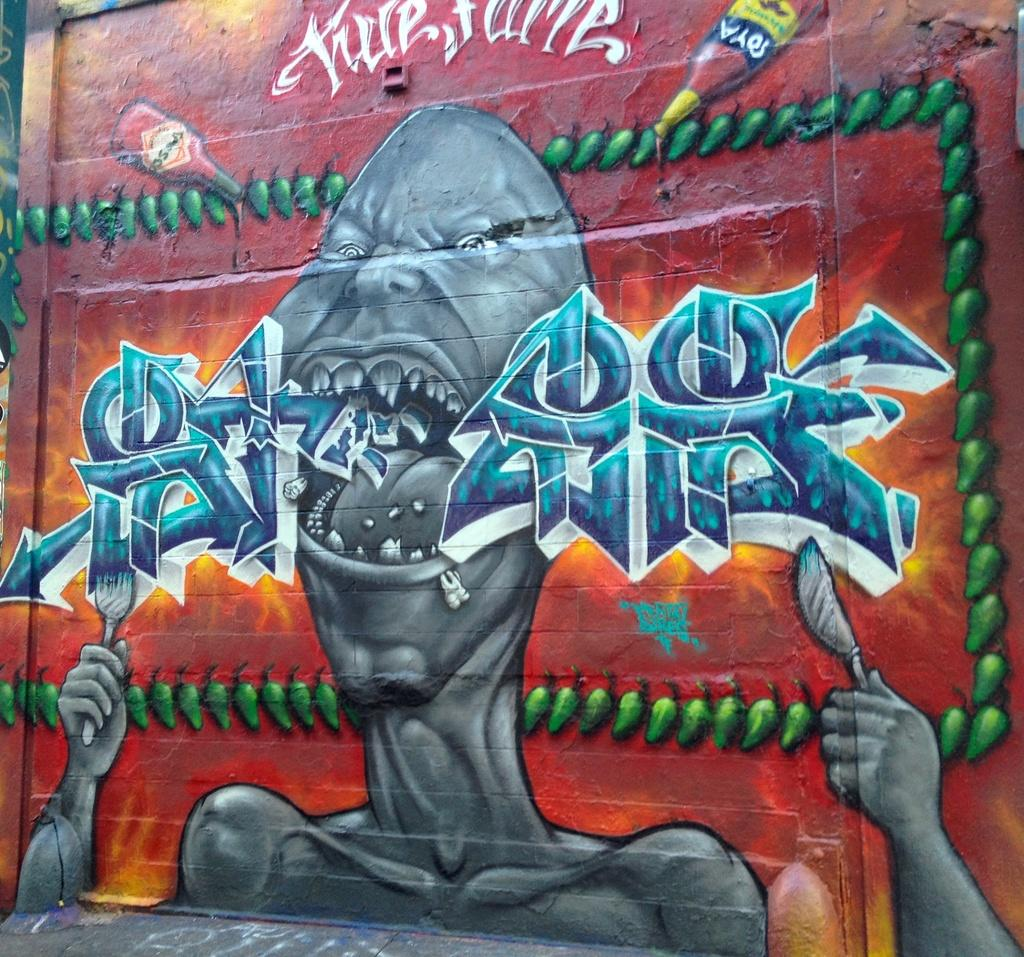What is present on the wall in the image? There is a painting on the wall in the image. What is the primary function of the wall in the image? The primary function of the wall is to provide support and structure to the surrounding area. What note is the cook playing on the wall in the image? There is no cook or musical instrument present on the wall in the image. 